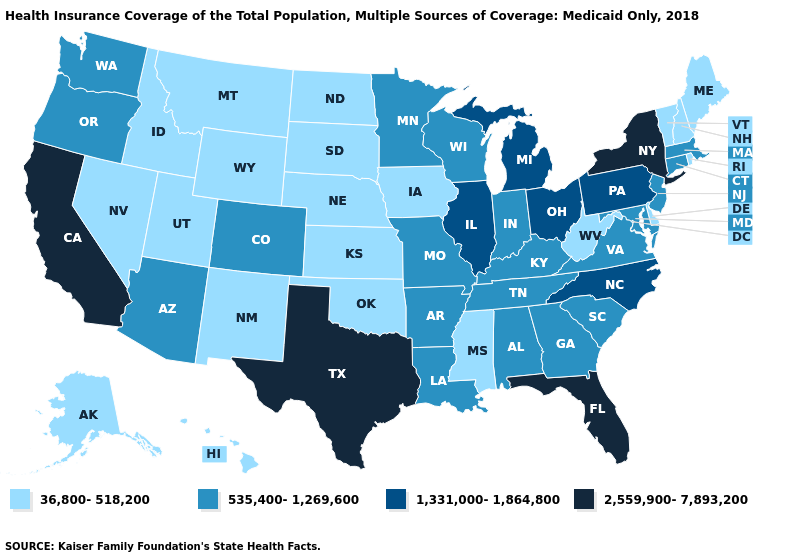What is the value of South Carolina?
Short answer required. 535,400-1,269,600. Which states have the highest value in the USA?
Write a very short answer. California, Florida, New York, Texas. Which states have the lowest value in the MidWest?
Quick response, please. Iowa, Kansas, Nebraska, North Dakota, South Dakota. Does Vermont have the lowest value in the Northeast?
Write a very short answer. Yes. What is the highest value in the West ?
Keep it brief. 2,559,900-7,893,200. Among the states that border Minnesota , which have the highest value?
Answer briefly. Wisconsin. Which states have the highest value in the USA?
Be succinct. California, Florida, New York, Texas. Which states have the lowest value in the Northeast?
Give a very brief answer. Maine, New Hampshire, Rhode Island, Vermont. What is the value of Montana?
Short answer required. 36,800-518,200. What is the lowest value in the South?
Answer briefly. 36,800-518,200. What is the lowest value in the West?
Answer briefly. 36,800-518,200. Name the states that have a value in the range 2,559,900-7,893,200?
Keep it brief. California, Florida, New York, Texas. Among the states that border Kansas , which have the highest value?
Write a very short answer. Colorado, Missouri. 